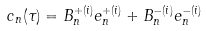Convert formula to latex. <formula><loc_0><loc_0><loc_500><loc_500>c _ { n } ( \tau ) = B _ { n } ^ { + ( i ) } e _ { n } ^ { + ( i ) } + B _ { n } ^ { - ( i ) } e _ { n } ^ { - ( i ) }</formula> 